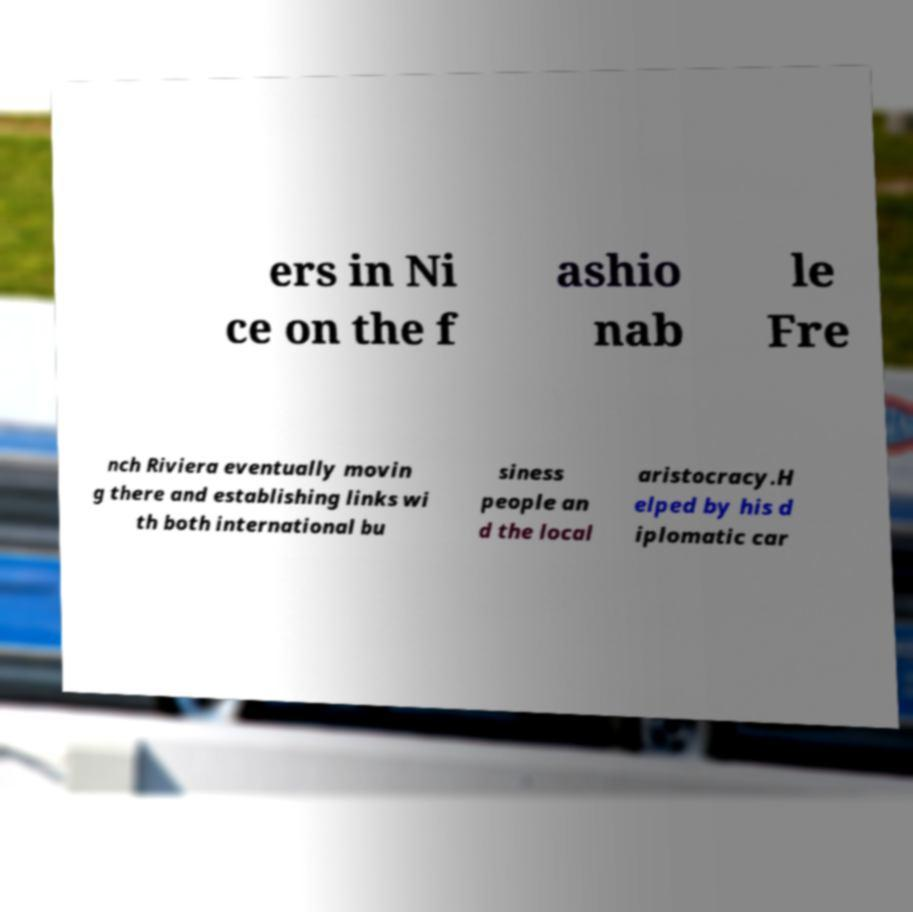For documentation purposes, I need the text within this image transcribed. Could you provide that? ers in Ni ce on the f ashio nab le Fre nch Riviera eventually movin g there and establishing links wi th both international bu siness people an d the local aristocracy.H elped by his d iplomatic car 